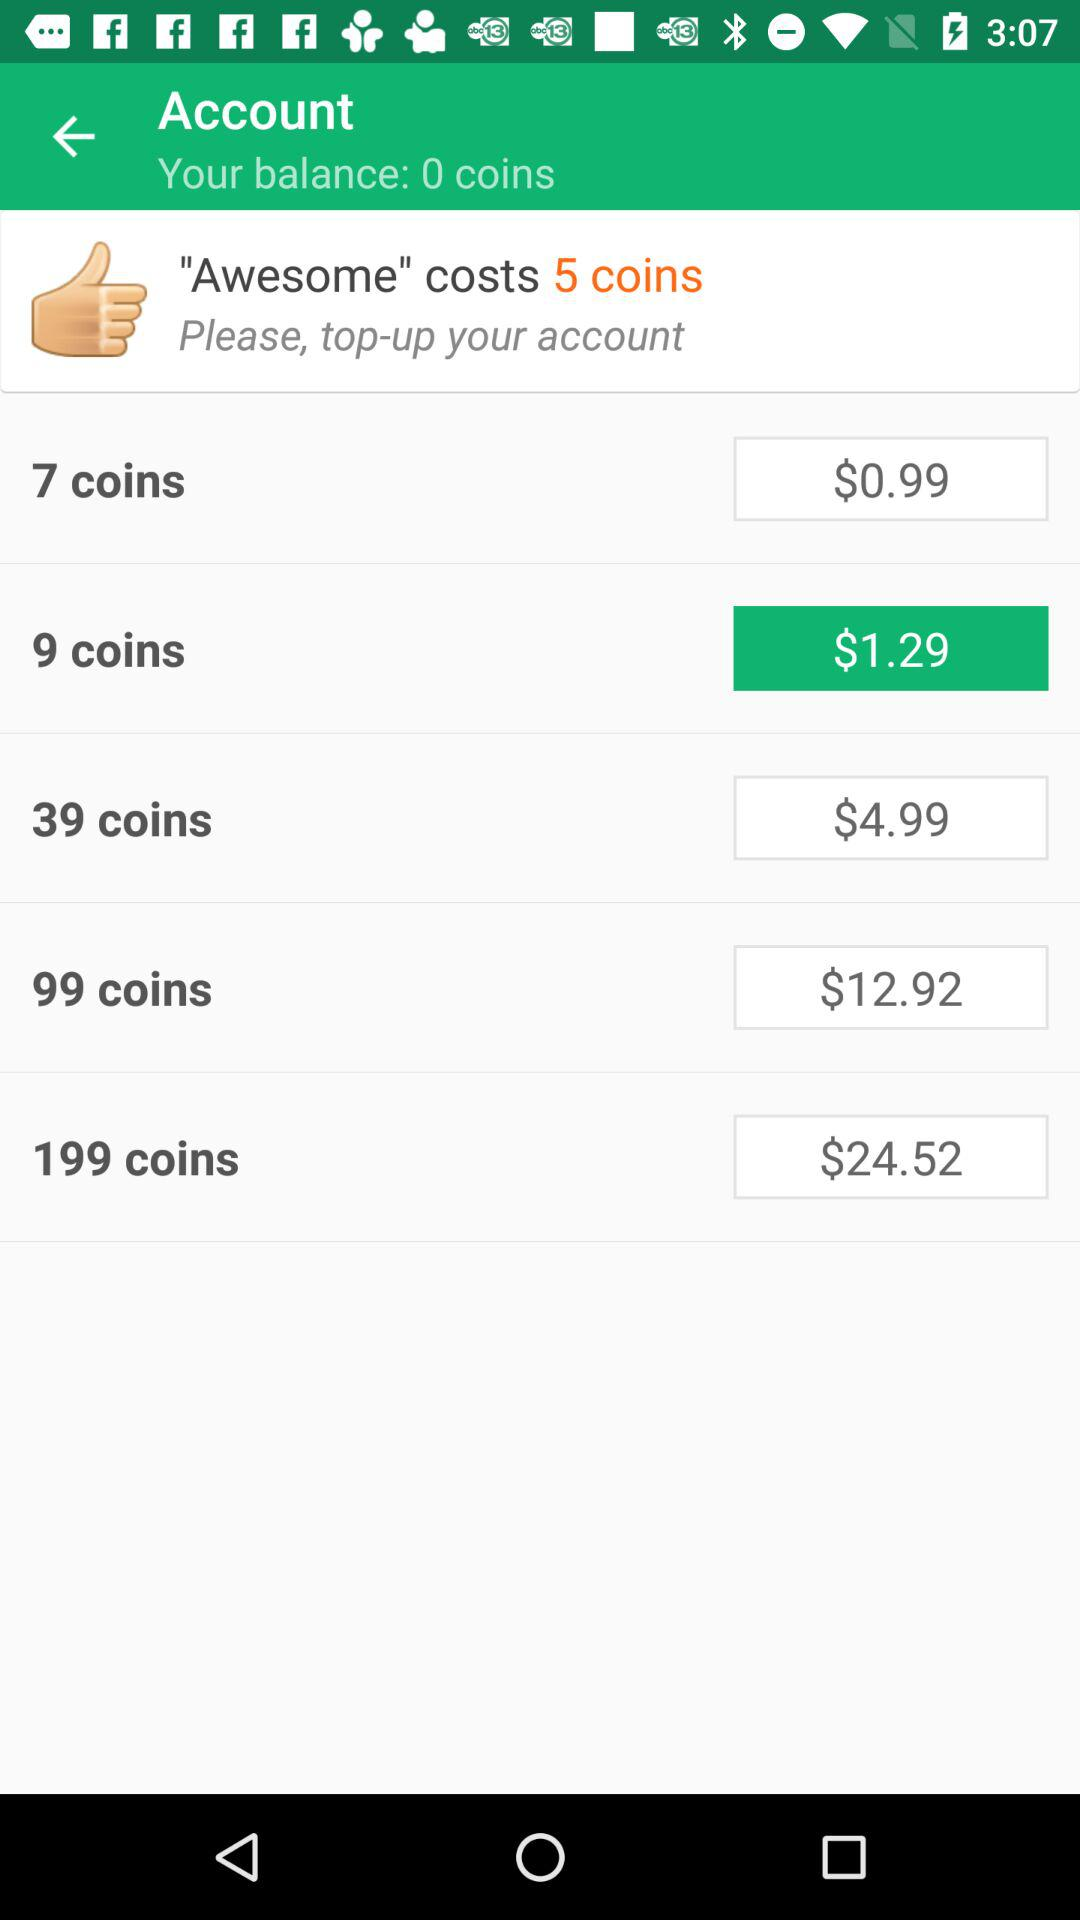Is there a coin package that offers the best value for money? The package that offers the best value for money is the 199 coins for $24.52, as it provides a larger number of coins per dollar compared to the other available options.  Can you calculate the cost per coin for each package? Certainly. For the 9 coins at $1.29, the cost per coin is approximately $0.143. For the 39 coins at $4.99, the cost per coin is about $0.128. For the 99 coins at $12.92, the cost per coin is roughly $0.130. Lastly, for the 199 coins at $24.52, the cost per coin is approximately $0.123, making it the most economical option. 